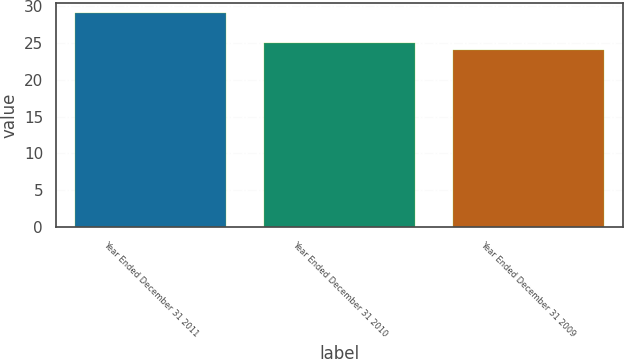<chart> <loc_0><loc_0><loc_500><loc_500><bar_chart><fcel>Year Ended December 31 2011<fcel>Year Ended December 31 2010<fcel>Year Ended December 31 2009<nl><fcel>29<fcel>25<fcel>24<nl></chart> 